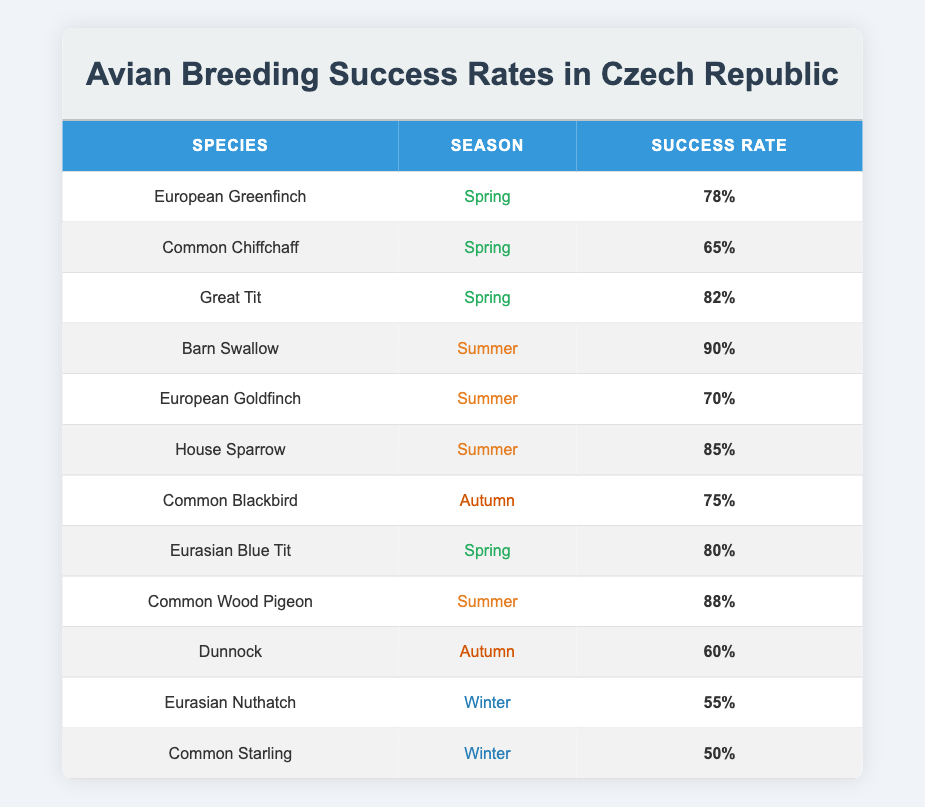What is the breeding success rate of the Barn Swallow in summer? The table shows that the Barn Swallow has a breeding success rate of 90% during the summer season.
Answer: 90% Which species has the highest breeding success rate in spring? By referring to the spring section of the table, the Great Tit has the highest breeding success rate of 82%.
Answer: Great Tit What is the average breeding success rate of avian species in autumn? The success rates for autumn are 75% for Common Blackbird and 60% for Dunnock. The average is (75 + 60) / 2 = 67.5%.
Answer: 67.5% Does the European Goldfinch have a breeding success rate higher than 70%? The table indicates that the European Goldfinch has a success rate of 70%, which means it does not exceed this threshold.
Answer: No How many species have a breeding success rate of 80% or higher during spring? The species that qualify are European Greenfinch (78%), Great Tit (82%), and Eurasian Blue Tit (80%). Therefore, two species meet or exceed 80%.
Answer: 2 What is the difference in success rates between the best and worst in winter? In winter, the Eurasian Nuthatch has a success rate of 55%, and the Common Starling has a rate of 50%. The difference is 55 - 50 = 5%.
Answer: 5% Which season has the highest average breeding success rate across all species listed? The success rates by season are: Spring (78 + 65 + 82 + 80 = 305 / 4), Summer (90 + 70 + 85 + 88 = 333 / 4), Autumn (75 + 60 = 135 / 2), Winter (55 + 50 = 105 / 2). The averages are: Spring (76.25%), Summer (83.25%), Autumn (67.5%), Winter (52.5%). Therefore, summer has the highest average success rate.
Answer: Summer Is it true that all species listed have a success rate of 60% or higher? By reviewing the table, the Common Starling at 50% and Eurasian Nuthatch at 55% do not meet the 60% threshold.
Answer: No What can be concluded about the breeding success rates in summer compared to winter? In summer, the lowest success rate is 70% (European Goldfinch), while in winter, it's 50% (Common Starling). Thus, summer has consistently higher breeding success rates than winter.
Answer: Summer has higher rates 